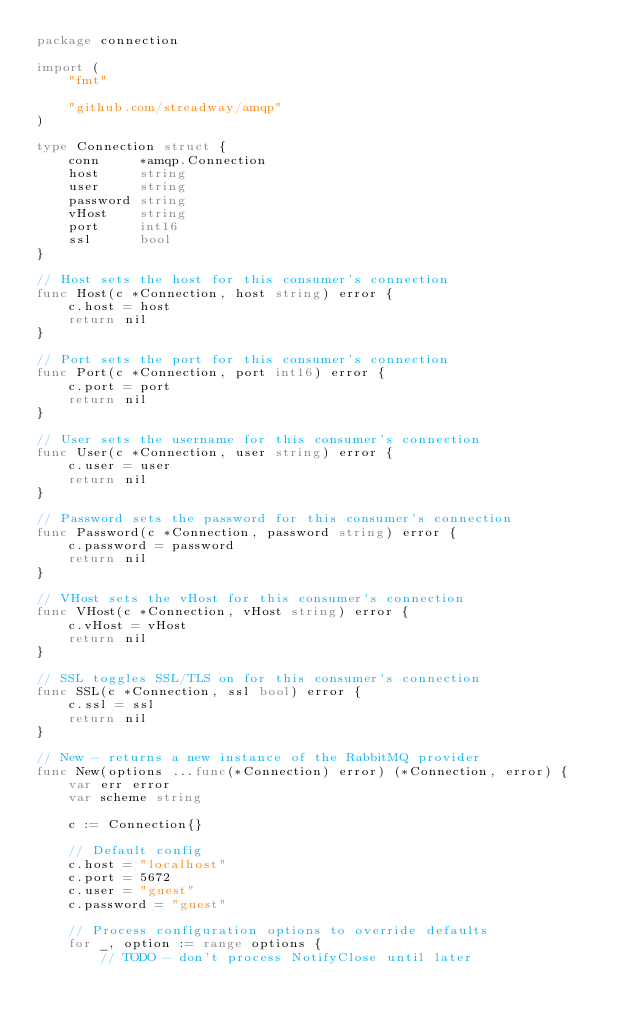Convert code to text. <code><loc_0><loc_0><loc_500><loc_500><_Go_>package connection

import (
	"fmt"

	"github.com/streadway/amqp"
)

type Connection struct {
	conn     *amqp.Connection
	host     string
	user     string
	password string
	vHost    string
	port     int16
	ssl      bool
}

// Host sets the host for this consumer's connection
func Host(c *Connection, host string) error {
	c.host = host
	return nil
}

// Port sets the port for this consumer's connection
func Port(c *Connection, port int16) error {
	c.port = port
	return nil
}

// User sets the username for this consumer's connection
func User(c *Connection, user string) error {
	c.user = user
	return nil
}

// Password sets the password for this consumer's connection
func Password(c *Connection, password string) error {
	c.password = password
	return nil
}

// VHost sets the vHost for this consumer's connection
func VHost(c *Connection, vHost string) error {
	c.vHost = vHost
	return nil
}

// SSL toggles SSL/TLS on for this consumer's connection
func SSL(c *Connection, ssl bool) error {
	c.ssl = ssl
	return nil
}

// New - returns a new instance of the RabbitMQ provider
func New(options ...func(*Connection) error) (*Connection, error) {
	var err error
	var scheme string

	c := Connection{}

	// Default config
	c.host = "localhost"
	c.port = 5672
	c.user = "guest"
	c.password = "guest"

	// Process configuration options to override defaults
	for _, option := range options {
		// TODO - don't process NotifyClose until later</code> 